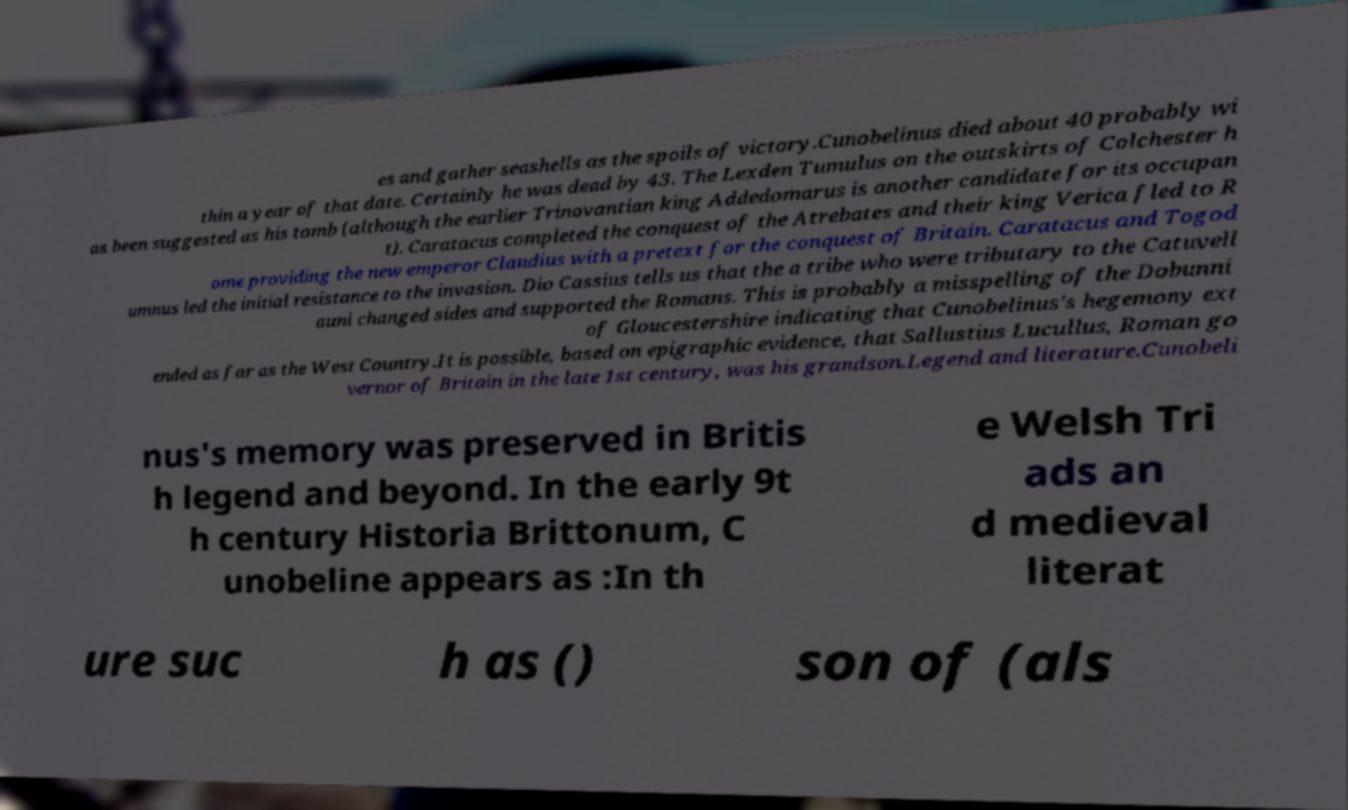Please read and relay the text visible in this image. What does it say? es and gather seashells as the spoils of victory.Cunobelinus died about 40 probably wi thin a year of that date. Certainly he was dead by 43. The Lexden Tumulus on the outskirts of Colchester h as been suggested as his tomb (although the earlier Trinovantian king Addedomarus is another candidate for its occupan t). Caratacus completed the conquest of the Atrebates and their king Verica fled to R ome providing the new emperor Claudius with a pretext for the conquest of Britain. Caratacus and Togod umnus led the initial resistance to the invasion. Dio Cassius tells us that the a tribe who were tributary to the Catuvell auni changed sides and supported the Romans. This is probably a misspelling of the Dobunni of Gloucestershire indicating that Cunobelinus's hegemony ext ended as far as the West Country.It is possible, based on epigraphic evidence, that Sallustius Lucullus, Roman go vernor of Britain in the late 1st century, was his grandson.Legend and literature.Cunobeli nus's memory was preserved in Britis h legend and beyond. In the early 9t h century Historia Brittonum, C unobeline appears as :In th e Welsh Tri ads an d medieval literat ure suc h as () son of (als 